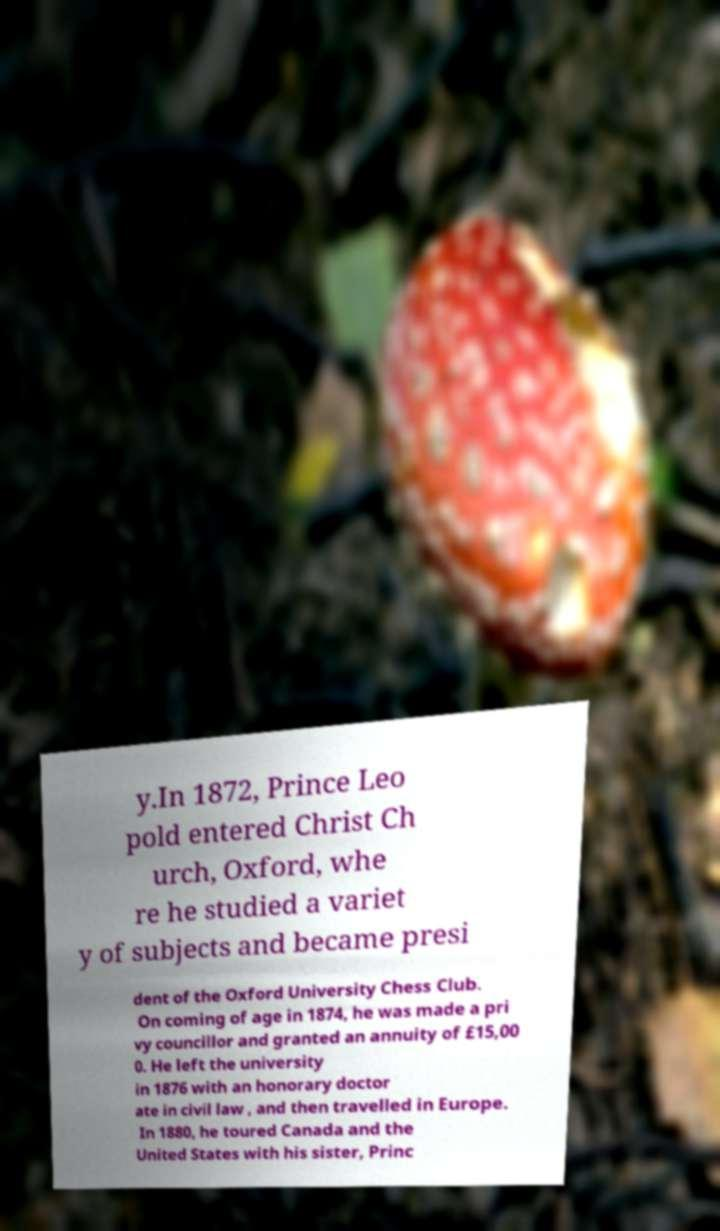Could you extract and type out the text from this image? y.In 1872, Prince Leo pold entered Christ Ch urch, Oxford, whe re he studied a variet y of subjects and became presi dent of the Oxford University Chess Club. On coming of age in 1874, he was made a pri vy councillor and granted an annuity of £15,00 0. He left the university in 1876 with an honorary doctor ate in civil law , and then travelled in Europe. In 1880, he toured Canada and the United States with his sister, Princ 